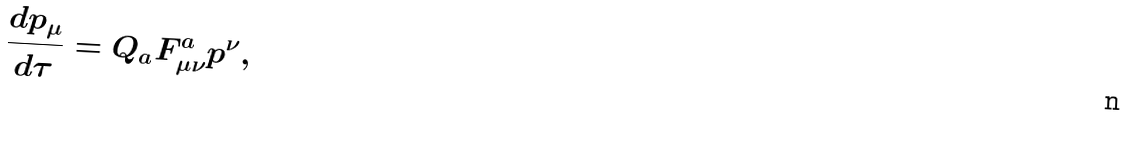<formula> <loc_0><loc_0><loc_500><loc_500>\frac { d p _ { \mu } } { d \tau } = Q _ { a } F ^ { a } _ { \mu \nu } p ^ { \nu } ,</formula> 